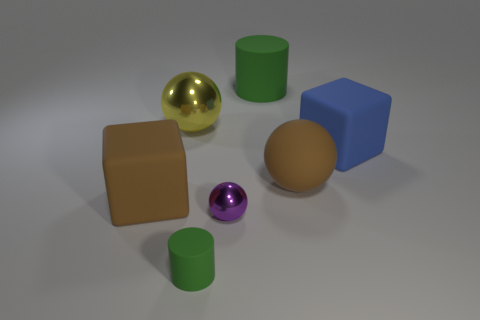Is there a tiny object that has the same material as the small purple ball?
Ensure brevity in your answer.  No. There is a green object that is the same size as the brown cube; what is its material?
Make the answer very short. Rubber. Are there fewer matte cylinders that are behind the yellow ball than brown things in front of the purple shiny ball?
Provide a short and direct response. No. There is a large thing that is to the left of the big green matte object and behind the brown matte ball; what is its shape?
Keep it short and to the point. Sphere. What number of other tiny green things are the same shape as the small green object?
Give a very brief answer. 0. What size is the ball that is the same material as the tiny cylinder?
Your answer should be compact. Large. Are there more big objects than tiny green cylinders?
Offer a terse response. Yes. What color is the sphere that is left of the small metal sphere?
Your answer should be compact. Yellow. What is the size of the matte thing that is both behind the purple sphere and in front of the matte sphere?
Offer a very short reply. Large. What number of other purple shiny balls have the same size as the purple ball?
Give a very brief answer. 0. 